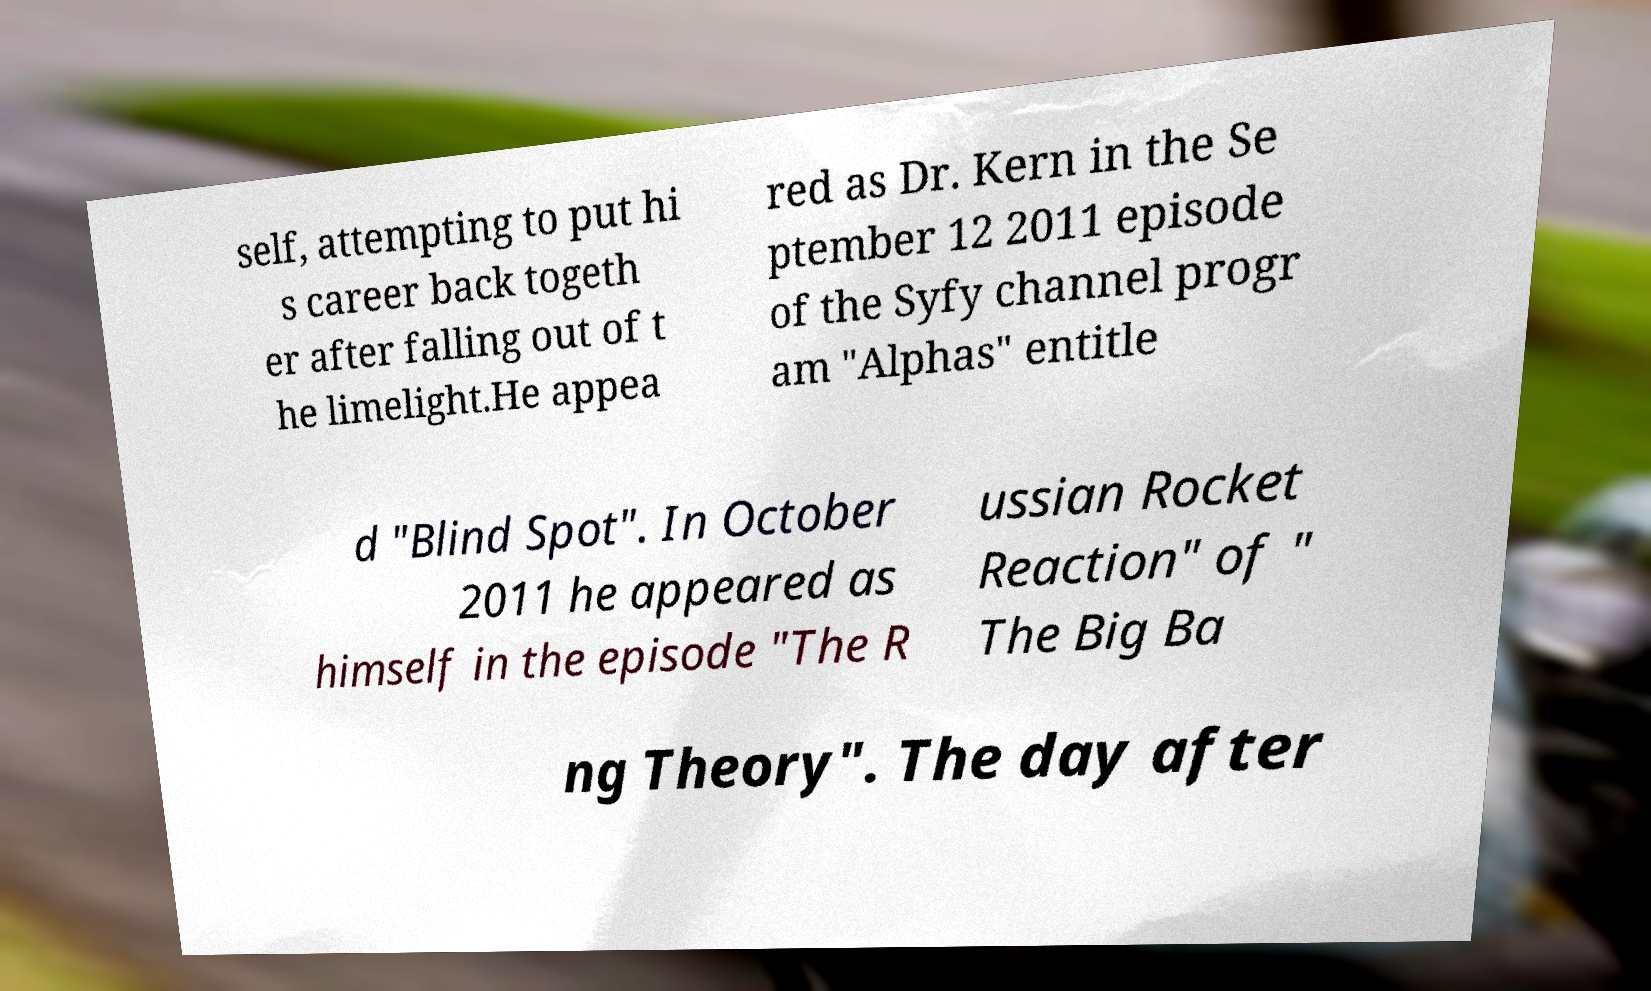Can you read and provide the text displayed in the image?This photo seems to have some interesting text. Can you extract and type it out for me? self, attempting to put hi s career back togeth er after falling out of t he limelight.He appea red as Dr. Kern in the Se ptember 12 2011 episode of the Syfy channel progr am "Alphas" entitle d "Blind Spot". In October 2011 he appeared as himself in the episode "The R ussian Rocket Reaction" of " The Big Ba ng Theory". The day after 